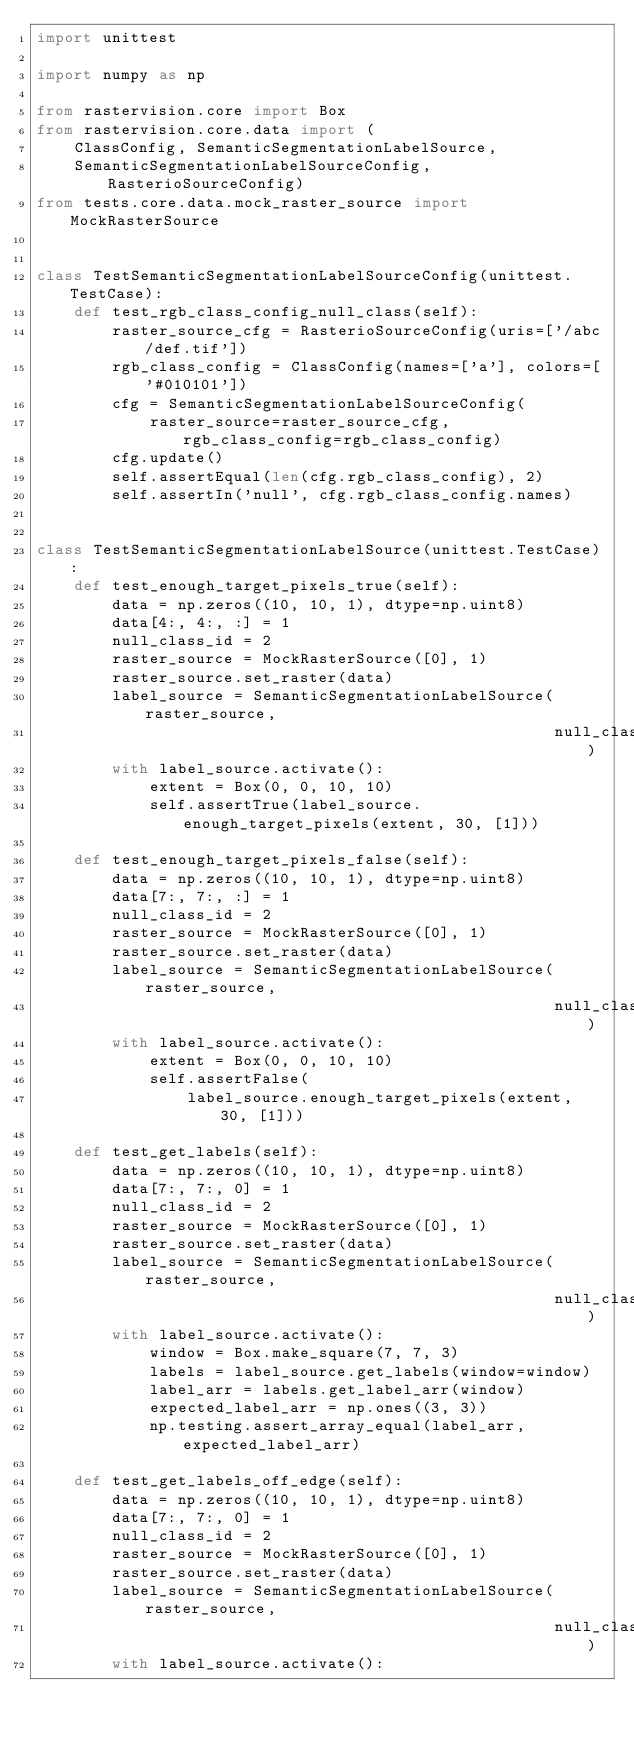Convert code to text. <code><loc_0><loc_0><loc_500><loc_500><_Python_>import unittest

import numpy as np

from rastervision.core import Box
from rastervision.core.data import (
    ClassConfig, SemanticSegmentationLabelSource,
    SemanticSegmentationLabelSourceConfig, RasterioSourceConfig)
from tests.core.data.mock_raster_source import MockRasterSource


class TestSemanticSegmentationLabelSourceConfig(unittest.TestCase):
    def test_rgb_class_config_null_class(self):
        raster_source_cfg = RasterioSourceConfig(uris=['/abc/def.tif'])
        rgb_class_config = ClassConfig(names=['a'], colors=['#010101'])
        cfg = SemanticSegmentationLabelSourceConfig(
            raster_source=raster_source_cfg, rgb_class_config=rgb_class_config)
        cfg.update()
        self.assertEqual(len(cfg.rgb_class_config), 2)
        self.assertIn('null', cfg.rgb_class_config.names)


class TestSemanticSegmentationLabelSource(unittest.TestCase):
    def test_enough_target_pixels_true(self):
        data = np.zeros((10, 10, 1), dtype=np.uint8)
        data[4:, 4:, :] = 1
        null_class_id = 2
        raster_source = MockRasterSource([0], 1)
        raster_source.set_raster(data)
        label_source = SemanticSegmentationLabelSource(raster_source,
                                                       null_class_id)
        with label_source.activate():
            extent = Box(0, 0, 10, 10)
            self.assertTrue(label_source.enough_target_pixels(extent, 30, [1]))

    def test_enough_target_pixels_false(self):
        data = np.zeros((10, 10, 1), dtype=np.uint8)
        data[7:, 7:, :] = 1
        null_class_id = 2
        raster_source = MockRasterSource([0], 1)
        raster_source.set_raster(data)
        label_source = SemanticSegmentationLabelSource(raster_source,
                                                       null_class_id)
        with label_source.activate():
            extent = Box(0, 0, 10, 10)
            self.assertFalse(
                label_source.enough_target_pixels(extent, 30, [1]))

    def test_get_labels(self):
        data = np.zeros((10, 10, 1), dtype=np.uint8)
        data[7:, 7:, 0] = 1
        null_class_id = 2
        raster_source = MockRasterSource([0], 1)
        raster_source.set_raster(data)
        label_source = SemanticSegmentationLabelSource(raster_source,
                                                       null_class_id)
        with label_source.activate():
            window = Box.make_square(7, 7, 3)
            labels = label_source.get_labels(window=window)
            label_arr = labels.get_label_arr(window)
            expected_label_arr = np.ones((3, 3))
            np.testing.assert_array_equal(label_arr, expected_label_arr)

    def test_get_labels_off_edge(self):
        data = np.zeros((10, 10, 1), dtype=np.uint8)
        data[7:, 7:, 0] = 1
        null_class_id = 2
        raster_source = MockRasterSource([0], 1)
        raster_source.set_raster(data)
        label_source = SemanticSegmentationLabelSource(raster_source,
                                                       null_class_id)
        with label_source.activate():</code> 